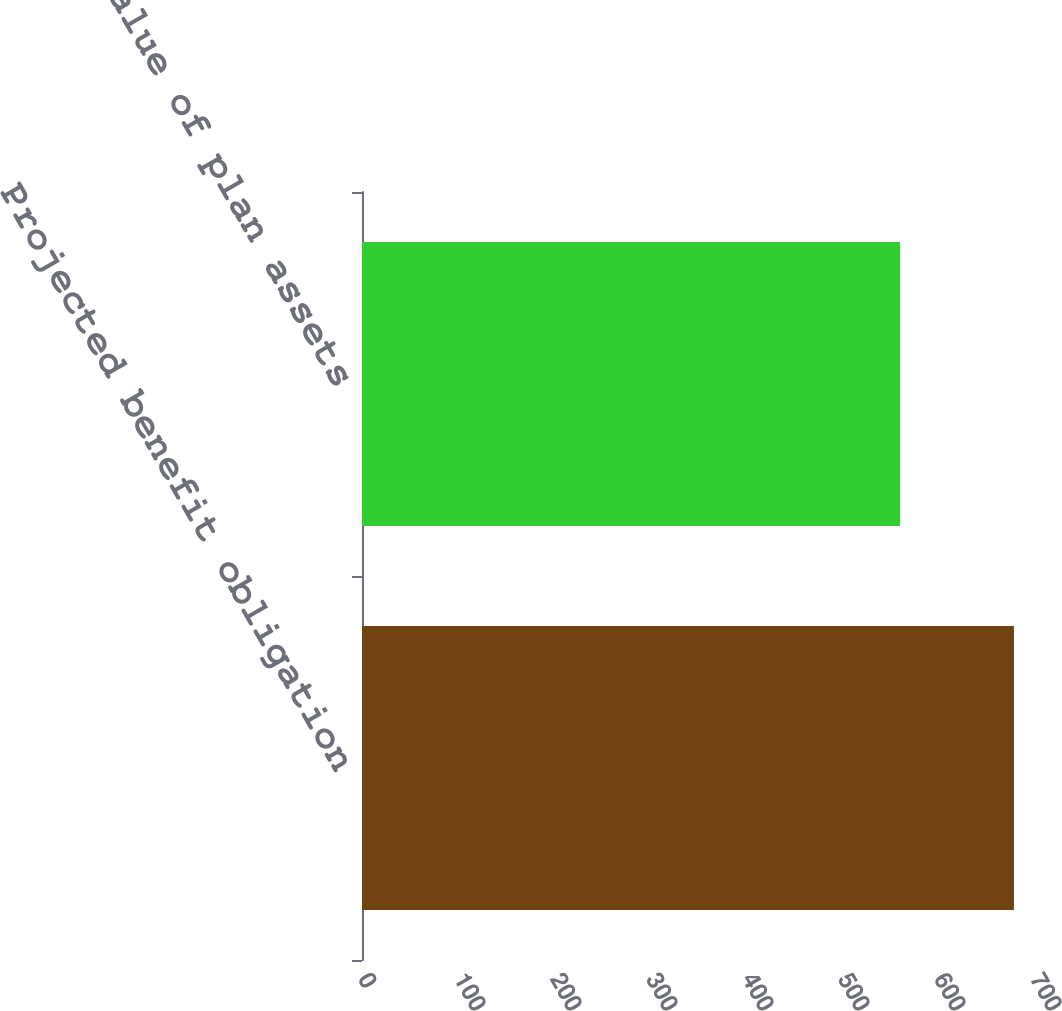Convert chart to OTSL. <chart><loc_0><loc_0><loc_500><loc_500><bar_chart><fcel>Projected benefit obligation<fcel>Fair value of plan assets<nl><fcel>679.1<fcel>560.6<nl></chart> 